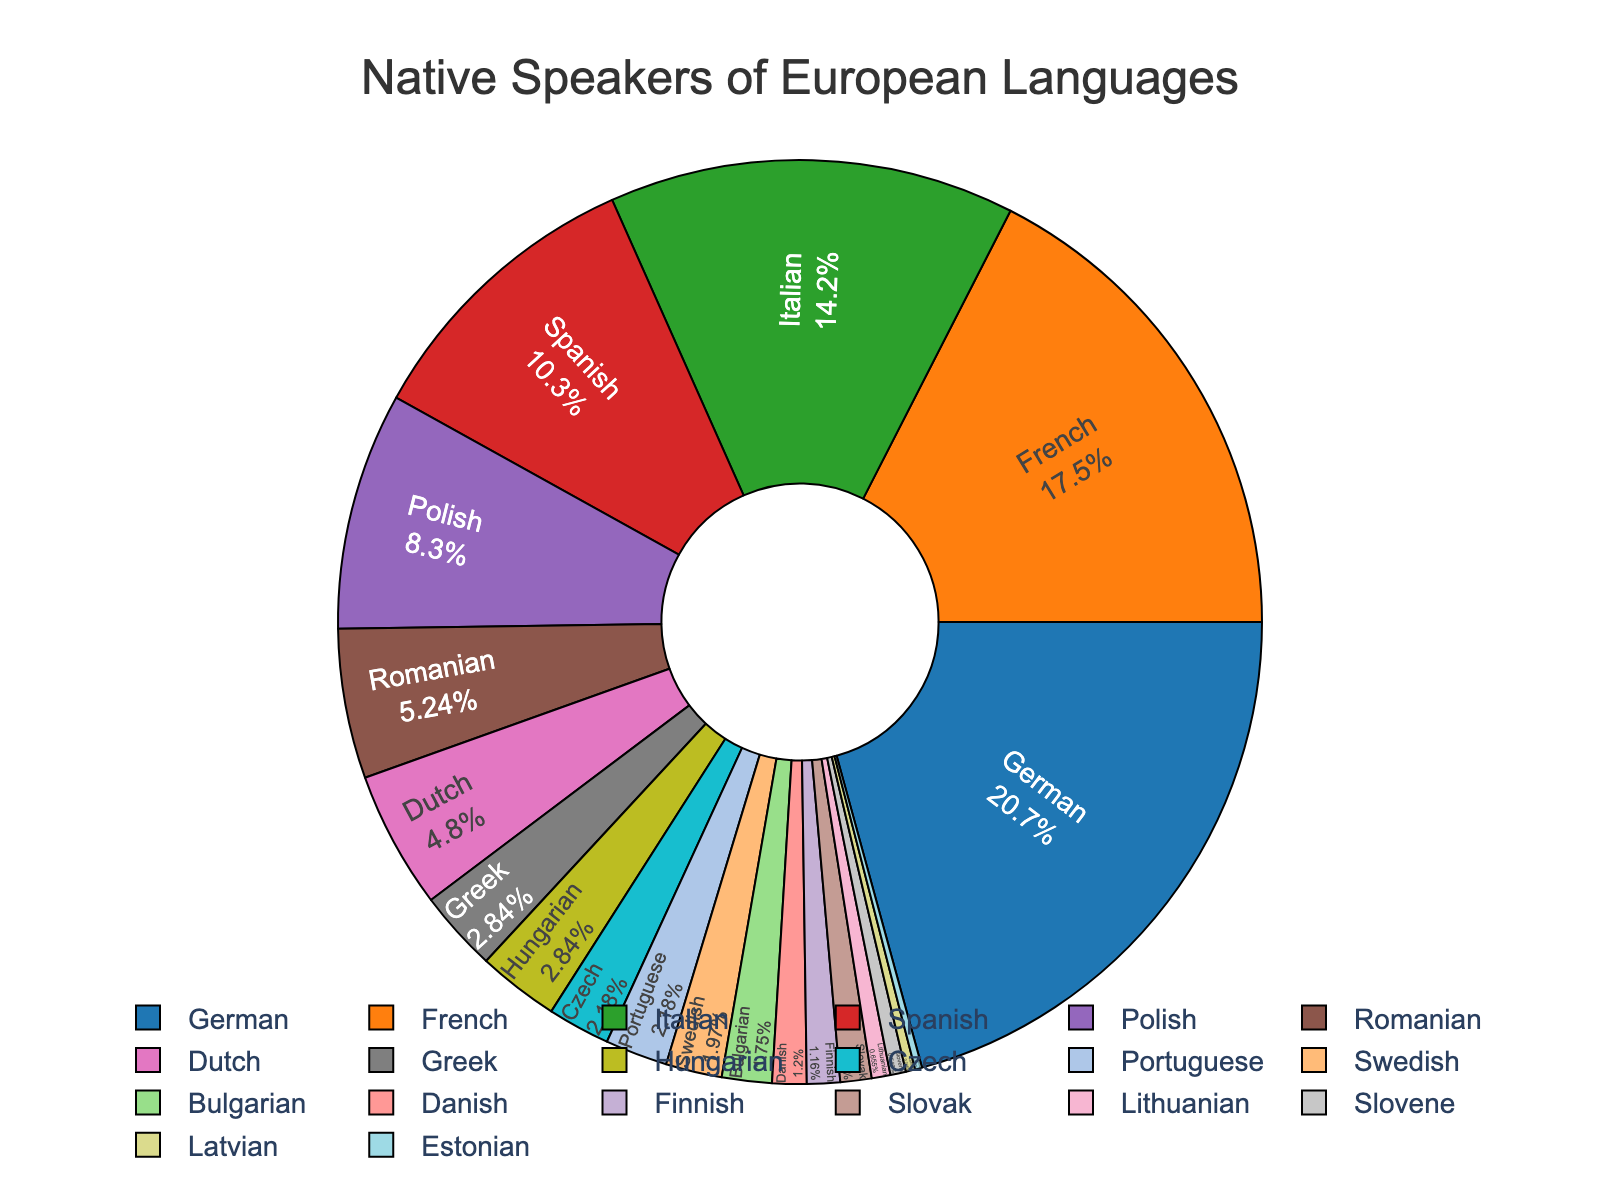Which language has the most native speakers? German has the largest percentage portion in the pie chart, indicating it has the highest number of native speakers.
Answer: German Compare the number of native speakers of German and French. How much more speakers does German have than French? The number of native speakers for German is 95 million, while French has 80 million. Thus, German has 95 - 80 = 15 million more native speakers than French.
Answer: 15 million What is the approximate percentage of native speakers for Italian? Italian occupies a significant portion of the pie chart. Given the data, the percentage can be calculated as (65/418)*100 ≈ 15.55%.
Answer: 15.55% Which language has the smallest number of native speakers, and what is their percentage in the pie chart? Estonian has the smallest portion in the pie chart. With 1.1 million out of 418 million total native speakers, the percentage is approximately (1.1/418)*100 ≈ 0.26%.
Answer: Estonian, 0.26% How much larger is the portion of Spanish compared to Portuguese in the pie chart? Spanish has 47 million native speakers while Portuguese has 10 million. Spanish has 37 million more native speakers, equating to (47/418)*100 ≈ 11.24%, and Portuguese equates to (10/418)*100 ≈ 2.39%. The difference in percentage is approximately 11.24% - 2.39% ≈ 8.85%.
Answer: 8.85% Which languages have approximately the same number of native speakers as Hungarian? Hungarian is shown with 13 million native speakers. Greek also has 13 million, as evident by their identical portion sizes on the chart.
Answer: Greek What fraction of the total native speakers is composed of speakers of the top three languages? The top three languages are German (95 million), French (80 million), and Italian (65 million). The total for these is 95 + 80 + 65 = 240 million. The total number of native speakers is 418 million, so the fraction is 240/418 ≈ 0.574.
Answer: 0.574 Calculate the cumulative percentage of native speakers for languages spoken by fewer than 5 million native speakers. Adding the languages: Slovak (5 million), Lithuanian (3 million), Slovene (2.5 million), Latvian (1.5 million), and Estonian (1.1 million), we get a total of 5 + 3 + 2.5 + 1.5 + 1.1 = 13.1 million. The cumulative percentage is (13.1/418)*100 ≈ 3.13%.
Answer: 3.13% Which languages represent more than 15% of the total native speakers? Calculating the proportion, 15% of 418 million is 0.15 * 418 = 62.7 million. German, French, and Italian exceed this threshold, having 95 million, 80 million, and 65 million speakers respectively.
Answer: German, French, Italian 